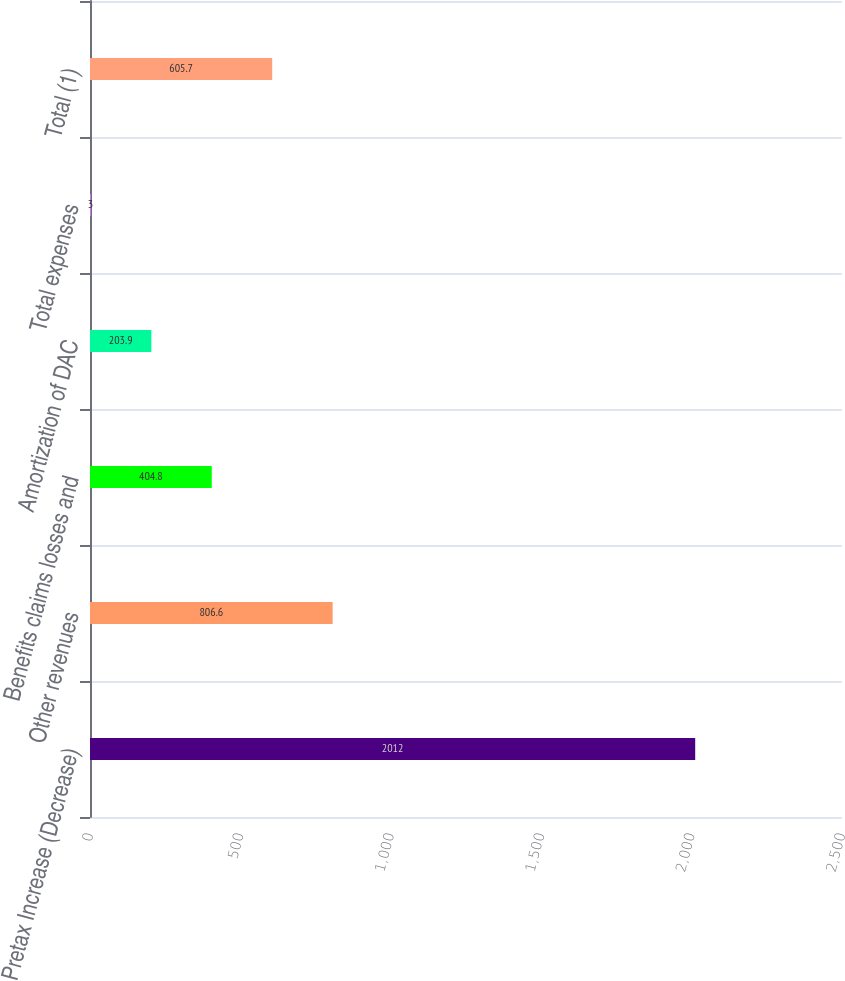Convert chart. <chart><loc_0><loc_0><loc_500><loc_500><bar_chart><fcel>Pretax Increase (Decrease)<fcel>Other revenues<fcel>Benefits claims losses and<fcel>Amortization of DAC<fcel>Total expenses<fcel>Total (1)<nl><fcel>2012<fcel>806.6<fcel>404.8<fcel>203.9<fcel>3<fcel>605.7<nl></chart> 